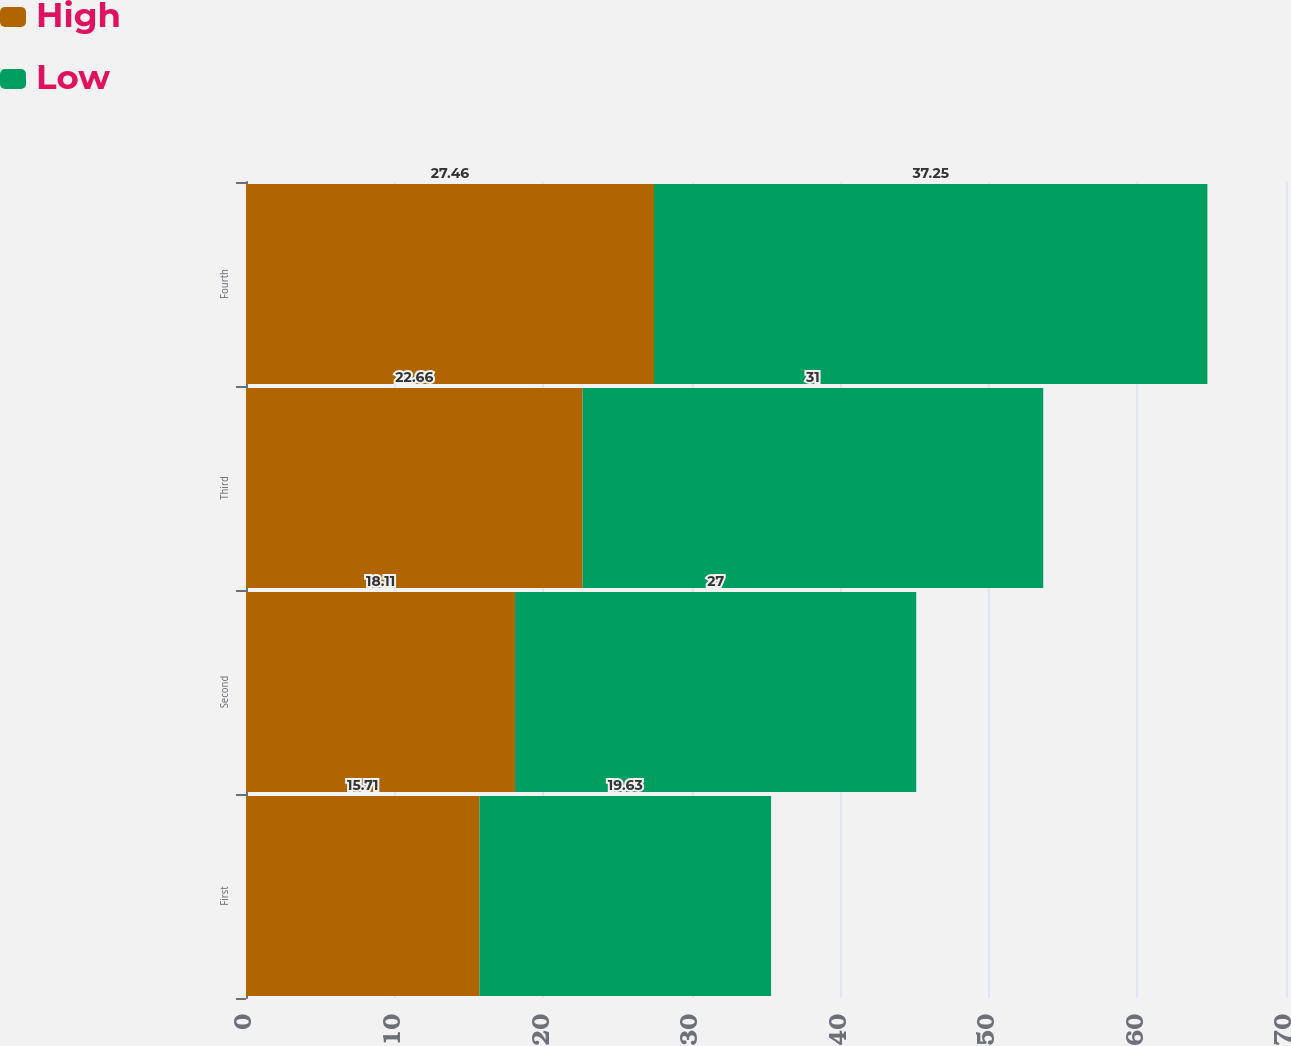<chart> <loc_0><loc_0><loc_500><loc_500><stacked_bar_chart><ecel><fcel>First<fcel>Second<fcel>Third<fcel>Fourth<nl><fcel>High<fcel>15.71<fcel>18.11<fcel>22.66<fcel>27.46<nl><fcel>Low<fcel>19.63<fcel>27<fcel>31<fcel>37.25<nl></chart> 